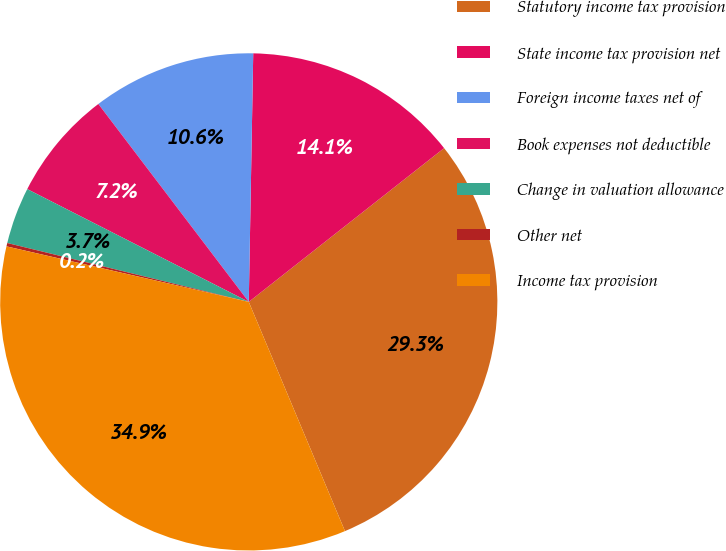<chart> <loc_0><loc_0><loc_500><loc_500><pie_chart><fcel>Statutory income tax provision<fcel>State income tax provision net<fcel>Foreign income taxes net of<fcel>Book expenses not deductible<fcel>Change in valuation allowance<fcel>Other net<fcel>Income tax provision<nl><fcel>29.29%<fcel>14.1%<fcel>10.63%<fcel>7.16%<fcel>3.69%<fcel>0.22%<fcel>34.91%<nl></chart> 